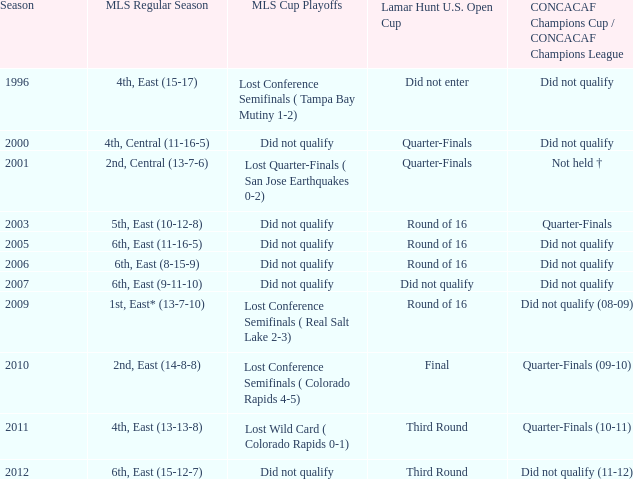What was the season when mls regular season was 6th, east (9-11-10)? 2007.0. 